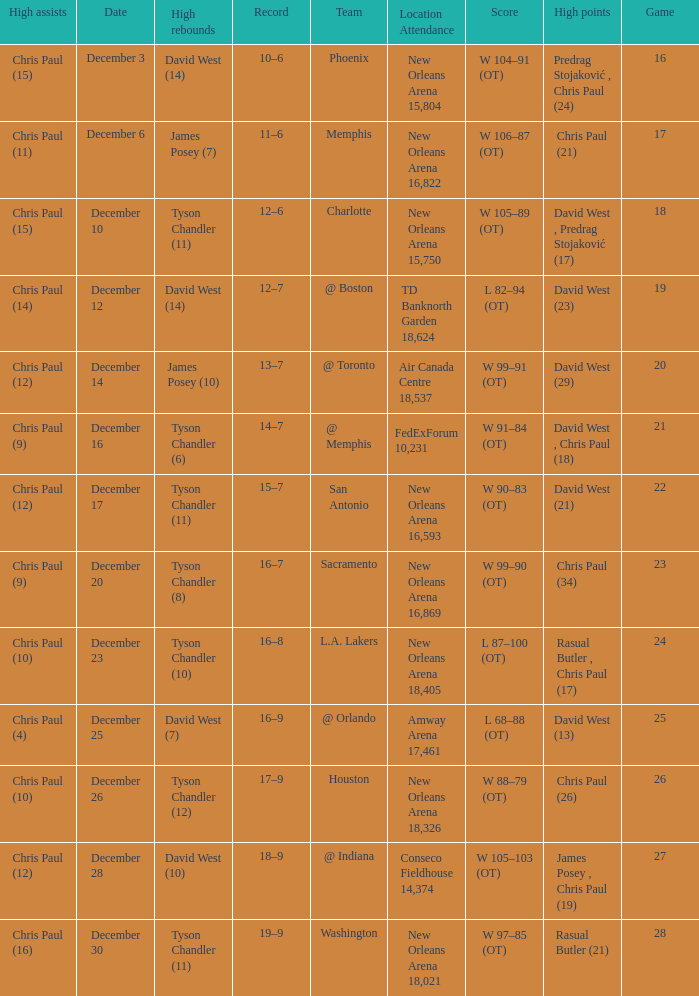What is the average Game, when Date is "December 23"? 24.0. 